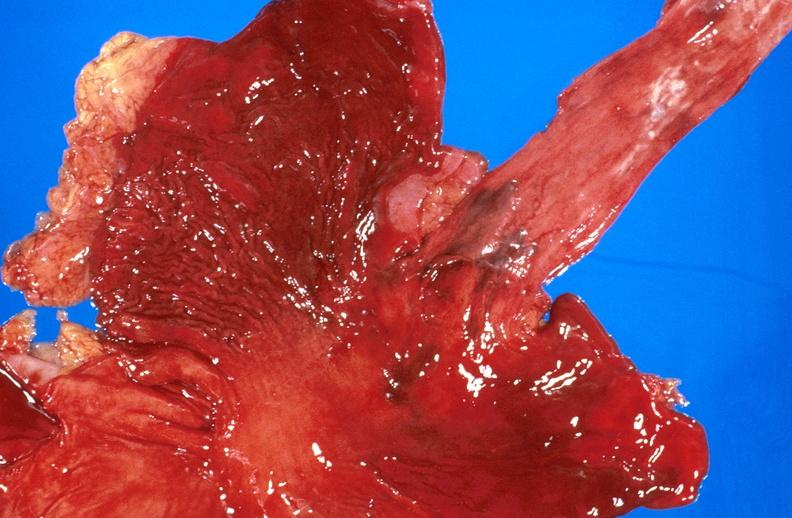s quite good liver present?
Answer the question using a single word or phrase. No 